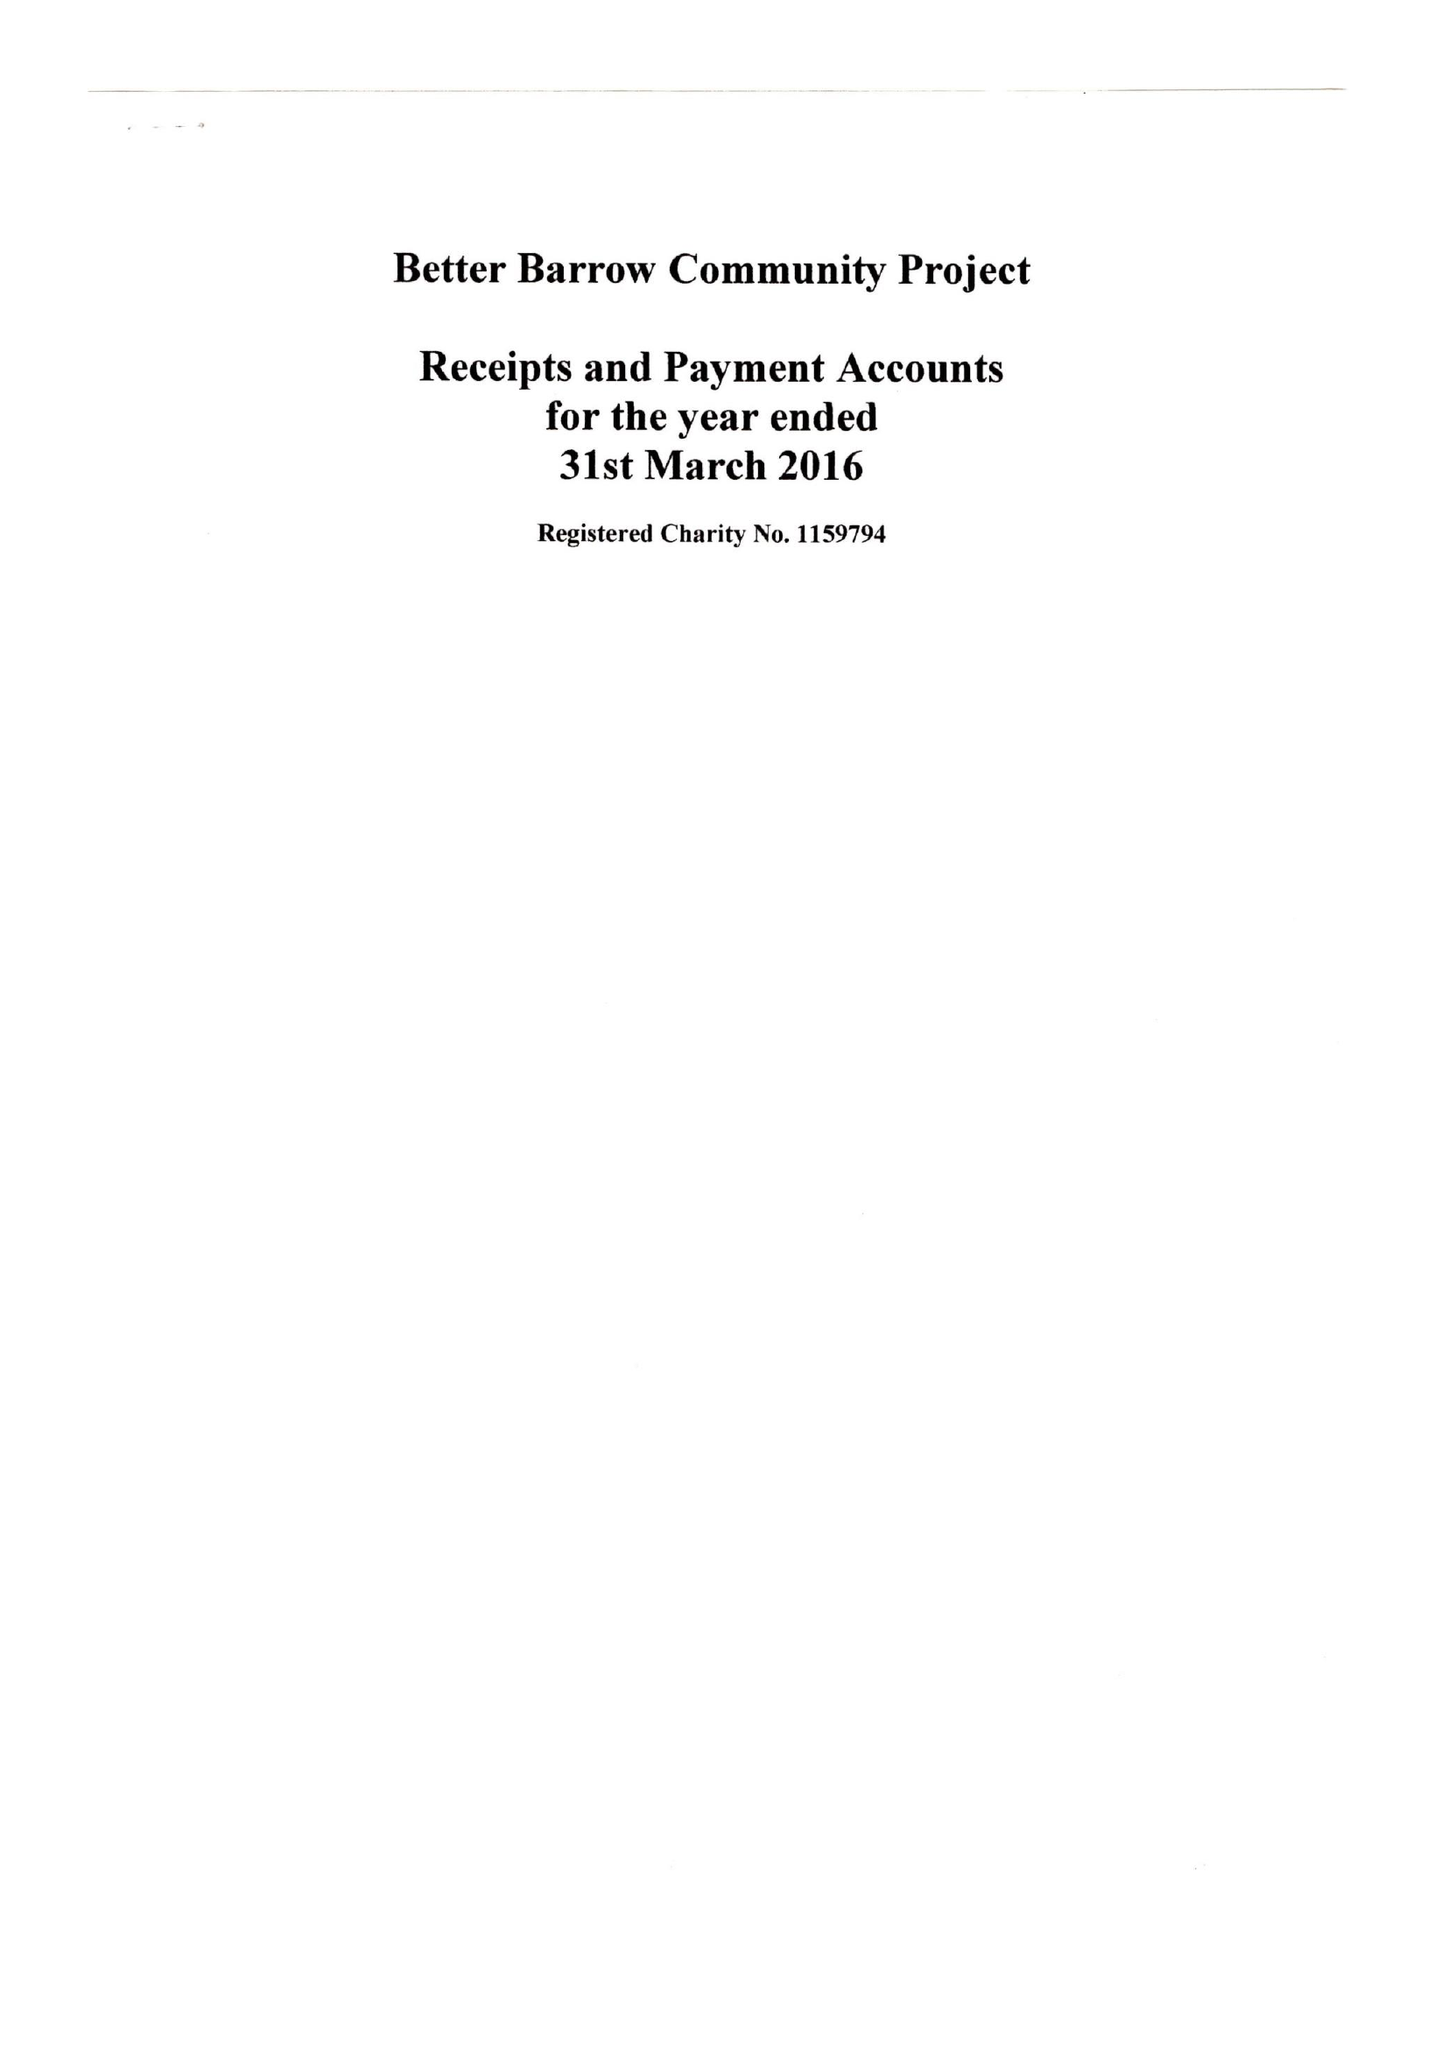What is the value for the charity_name?
Answer the question using a single word or phrase. Better Barrow Community Project 